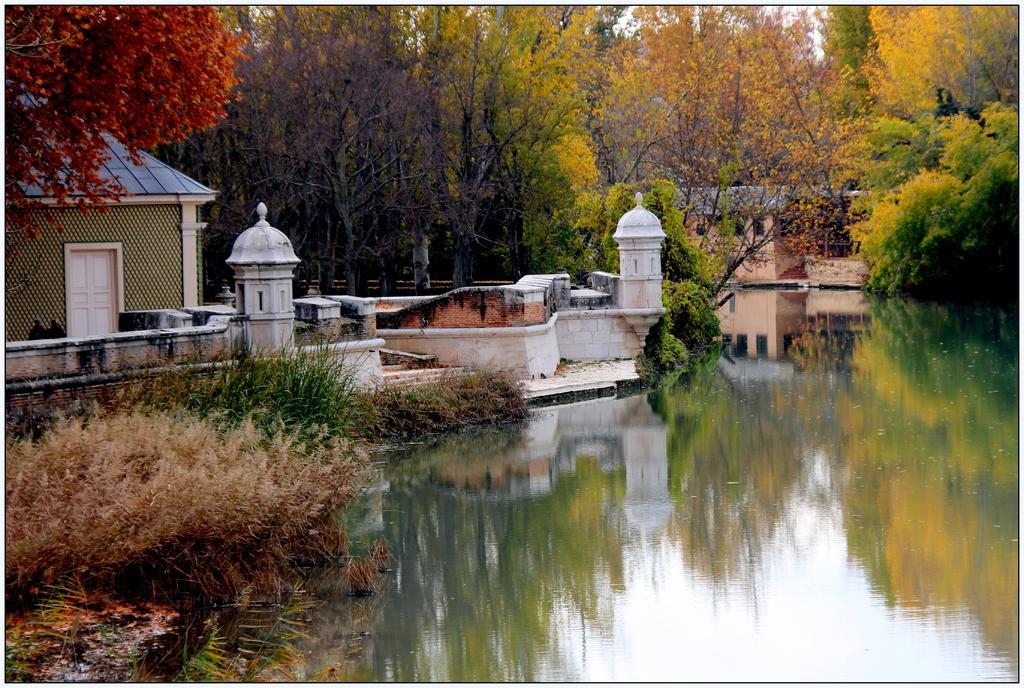Could you give a brief overview of what you see in this image? In this image we can see water, grass, buildings and trees. 